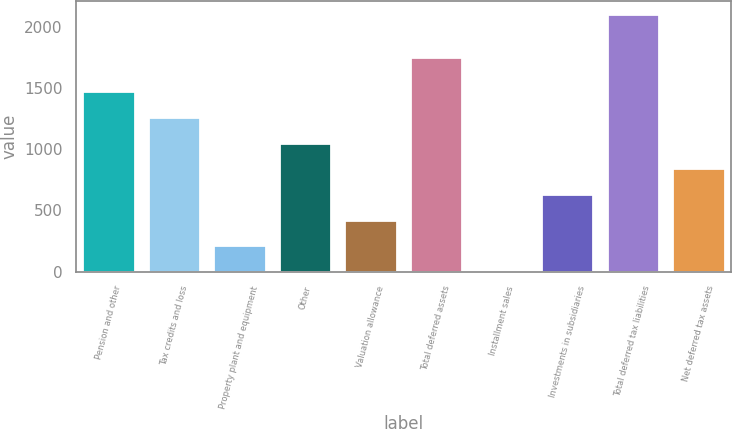Convert chart to OTSL. <chart><loc_0><loc_0><loc_500><loc_500><bar_chart><fcel>Pension and other<fcel>Tax credits and loss<fcel>Property plant and equipment<fcel>Other<fcel>Valuation allowance<fcel>Total deferred assets<fcel>Installment sales<fcel>Investments in subsidiaries<fcel>Total deferred tax liabilities<fcel>Net deferred tax assets<nl><fcel>1474.6<fcel>1264.8<fcel>215.8<fcel>1055<fcel>425.6<fcel>1755<fcel>6<fcel>635.4<fcel>2104<fcel>845.2<nl></chart> 